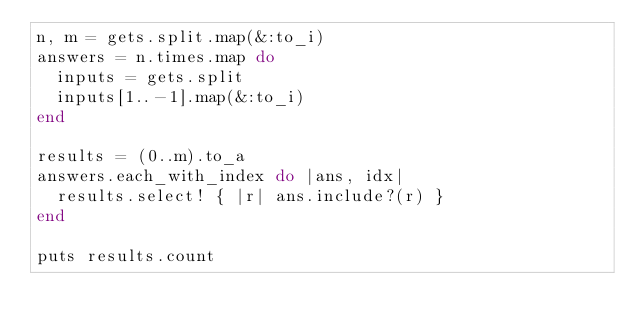<code> <loc_0><loc_0><loc_500><loc_500><_Ruby_>n, m = gets.split.map(&:to_i)
answers = n.times.map do
  inputs = gets.split
  inputs[1..-1].map(&:to_i)
end

results = (0..m).to_a
answers.each_with_index do |ans, idx|
  results.select! { |r| ans.include?(r) }
end

puts results.count
</code> 